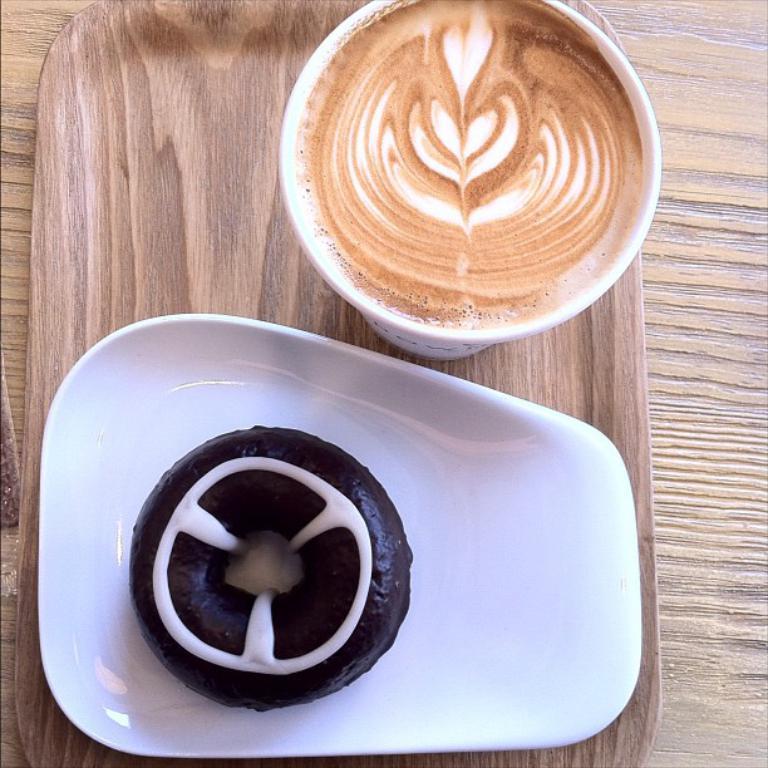Describe this image in one or two sentences. Here in this picture we can see a table, on which we can see a tray with a cup of coffee and a doughnut present on a plate. 